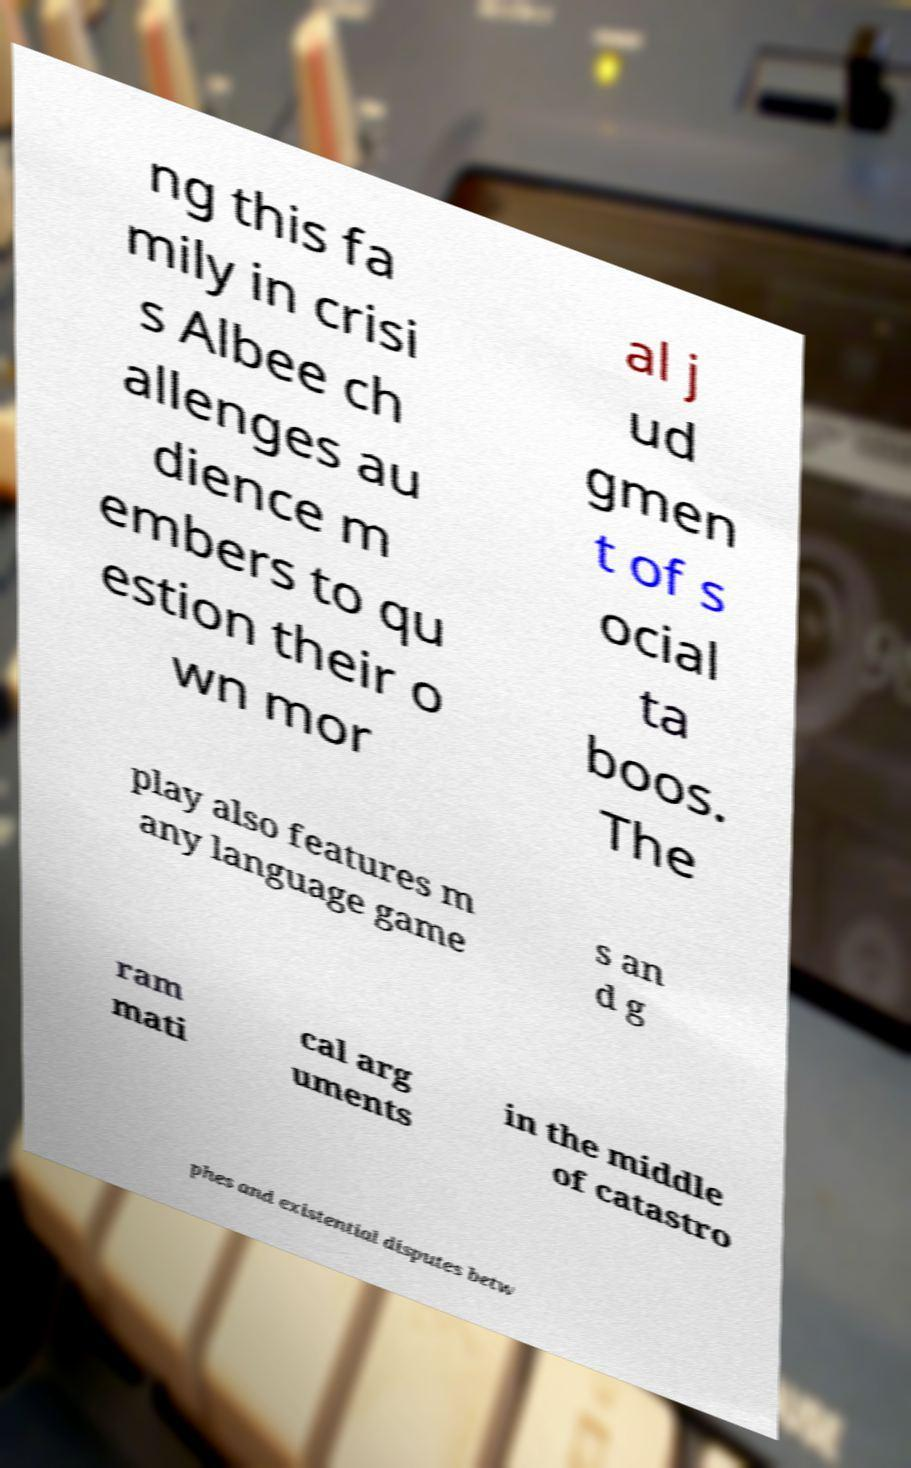For documentation purposes, I need the text within this image transcribed. Could you provide that? ng this fa mily in crisi s Albee ch allenges au dience m embers to qu estion their o wn mor al j ud gmen t of s ocial ta boos. The play also features m any language game s an d g ram mati cal arg uments in the middle of catastro phes and existential disputes betw 